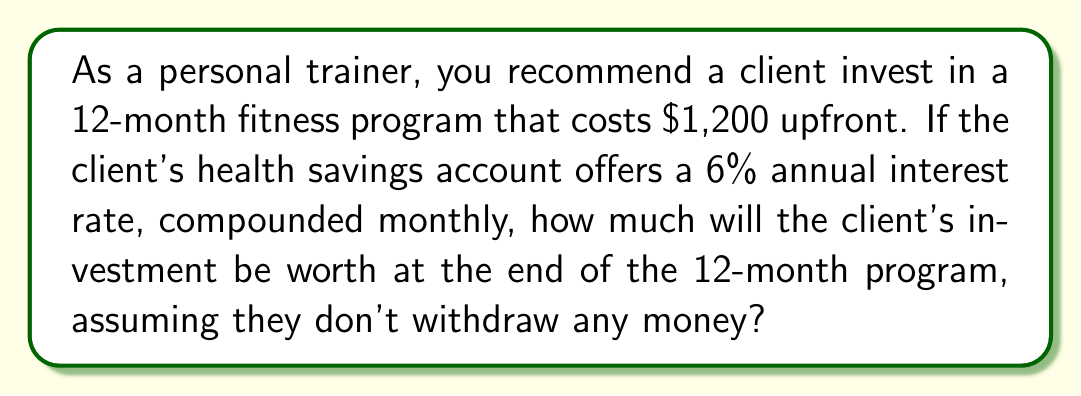Give your solution to this math problem. To solve this problem, we'll use the compound interest formula:

$$A = P(1 + \frac{r}{n})^{nt}$$

Where:
$A$ = final amount
$P$ = principal (initial investment)
$r$ = annual interest rate (as a decimal)
$n$ = number of times interest is compounded per year
$t$ = number of years

Given:
$P = 1200$
$r = 0.06$ (6% converted to decimal)
$n = 12$ (compounded monthly)
$t = 1$ (12-month program = 1 year)

Let's substitute these values into the formula:

$$A = 1200(1 + \frac{0.06}{12})^{12 \cdot 1}$$

$$A = 1200(1 + 0.005)^{12}$$

$$A = 1200(1.005)^{12}$$

Now, let's calculate $(1.005)^{12}$:

$$(1.005)^{12} \approx 1.0616778$$

Multiplying this by the principal:

$$A = 1200 \cdot 1.0616778 \approx 1274.01$$

Therefore, the client's investment will be worth approximately $1,274.01 at the end of the 12-month program.
Answer: $1,274.01 